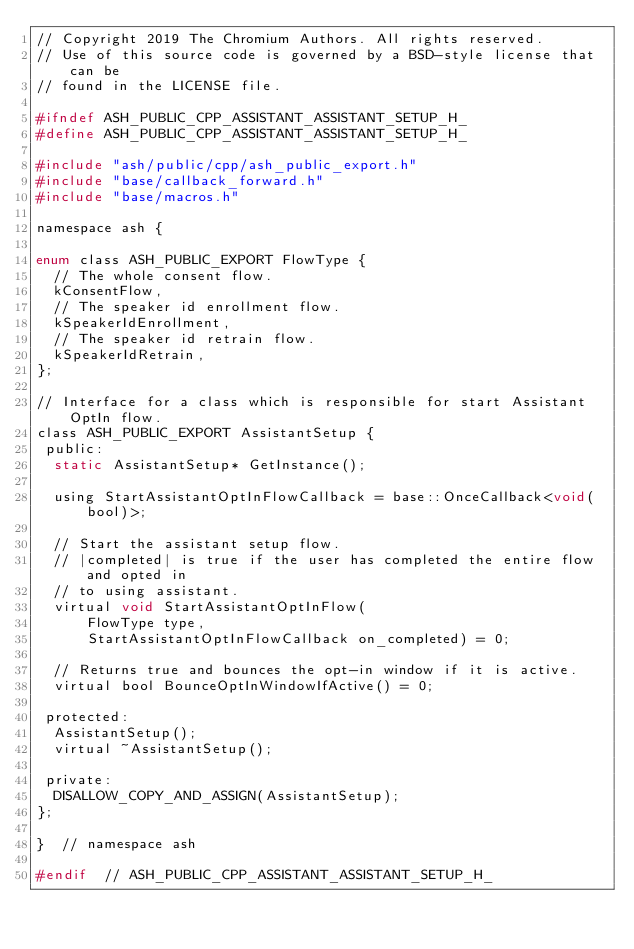Convert code to text. <code><loc_0><loc_0><loc_500><loc_500><_C_>// Copyright 2019 The Chromium Authors. All rights reserved.
// Use of this source code is governed by a BSD-style license that can be
// found in the LICENSE file.

#ifndef ASH_PUBLIC_CPP_ASSISTANT_ASSISTANT_SETUP_H_
#define ASH_PUBLIC_CPP_ASSISTANT_ASSISTANT_SETUP_H_

#include "ash/public/cpp/ash_public_export.h"
#include "base/callback_forward.h"
#include "base/macros.h"

namespace ash {

enum class ASH_PUBLIC_EXPORT FlowType {
  // The whole consent flow.
  kConsentFlow,
  // The speaker id enrollment flow.
  kSpeakerIdEnrollment,
  // The speaker id retrain flow.
  kSpeakerIdRetrain,
};

// Interface for a class which is responsible for start Assistant OptIn flow.
class ASH_PUBLIC_EXPORT AssistantSetup {
 public:
  static AssistantSetup* GetInstance();

  using StartAssistantOptInFlowCallback = base::OnceCallback<void(bool)>;

  // Start the assistant setup flow.
  // |completed| is true if the user has completed the entire flow and opted in
  // to using assistant.
  virtual void StartAssistantOptInFlow(
      FlowType type,
      StartAssistantOptInFlowCallback on_completed) = 0;

  // Returns true and bounces the opt-in window if it is active.
  virtual bool BounceOptInWindowIfActive() = 0;

 protected:
  AssistantSetup();
  virtual ~AssistantSetup();

 private:
  DISALLOW_COPY_AND_ASSIGN(AssistantSetup);
};

}  // namespace ash

#endif  // ASH_PUBLIC_CPP_ASSISTANT_ASSISTANT_SETUP_H_
</code> 